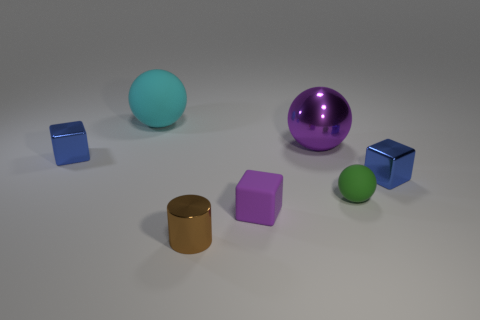Add 2 large blue matte cylinders. How many objects exist? 9 Subtract all cubes. How many objects are left? 4 Subtract all large cyan shiny cylinders. Subtract all small metal cubes. How many objects are left? 5 Add 7 purple things. How many purple things are left? 9 Add 3 green things. How many green things exist? 4 Subtract 1 green spheres. How many objects are left? 6 